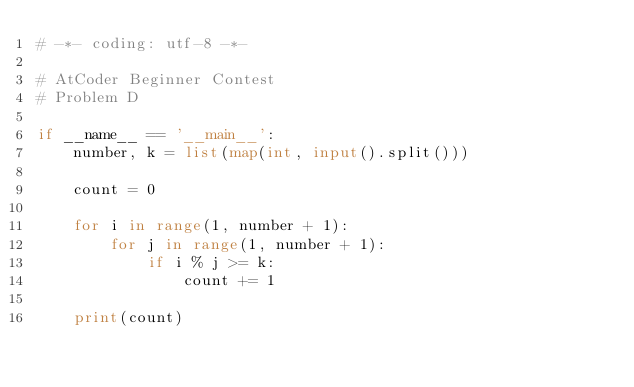Convert code to text. <code><loc_0><loc_0><loc_500><loc_500><_Python_># -*- coding: utf-8 -*-

# AtCoder Beginner Contest
# Problem D

if __name__ == '__main__':
    number, k = list(map(int, input().split()))

    count = 0

    for i in range(1, number + 1):
        for j in range(1, number + 1):
            if i % j >= k:
                count += 1

    print(count)
</code> 